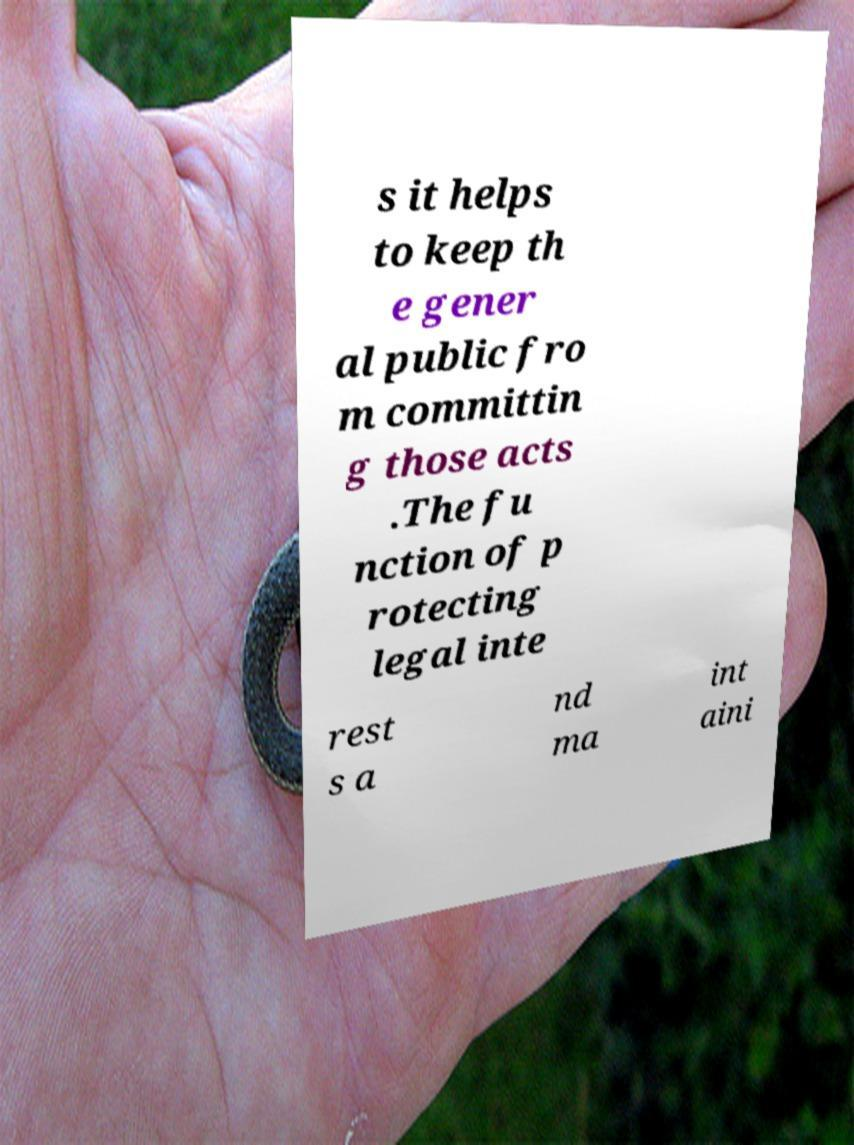What messages or text are displayed in this image? I need them in a readable, typed format. s it helps to keep th e gener al public fro m committin g those acts .The fu nction of p rotecting legal inte rest s a nd ma int aini 